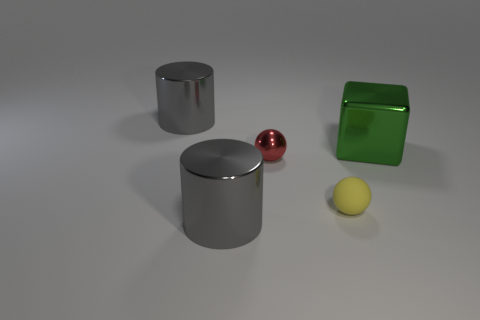Are there any other things that are made of the same material as the yellow sphere?
Provide a succinct answer. No. The gray object that is behind the yellow matte object that is to the right of the cylinder behind the yellow rubber object is what shape?
Keep it short and to the point. Cylinder. What number of other small yellow objects have the same shape as the tiny matte object?
Your answer should be compact. 0. How many gray objects are behind the gray cylinder that is in front of the big green shiny object?
Your answer should be compact. 1. What number of metallic things are big gray cylinders or purple spheres?
Offer a terse response. 2. Is there a tiny red thing made of the same material as the green object?
Ensure brevity in your answer.  Yes. How many things are either gray shiny objects in front of the yellow object or gray things in front of the small yellow sphere?
Make the answer very short. 1. Do the big metallic object on the right side of the red shiny ball and the tiny shiny thing have the same color?
Provide a succinct answer. No. How many other things are there of the same color as the big metal cube?
Provide a succinct answer. 0. What material is the small red sphere?
Your answer should be compact. Metal. 